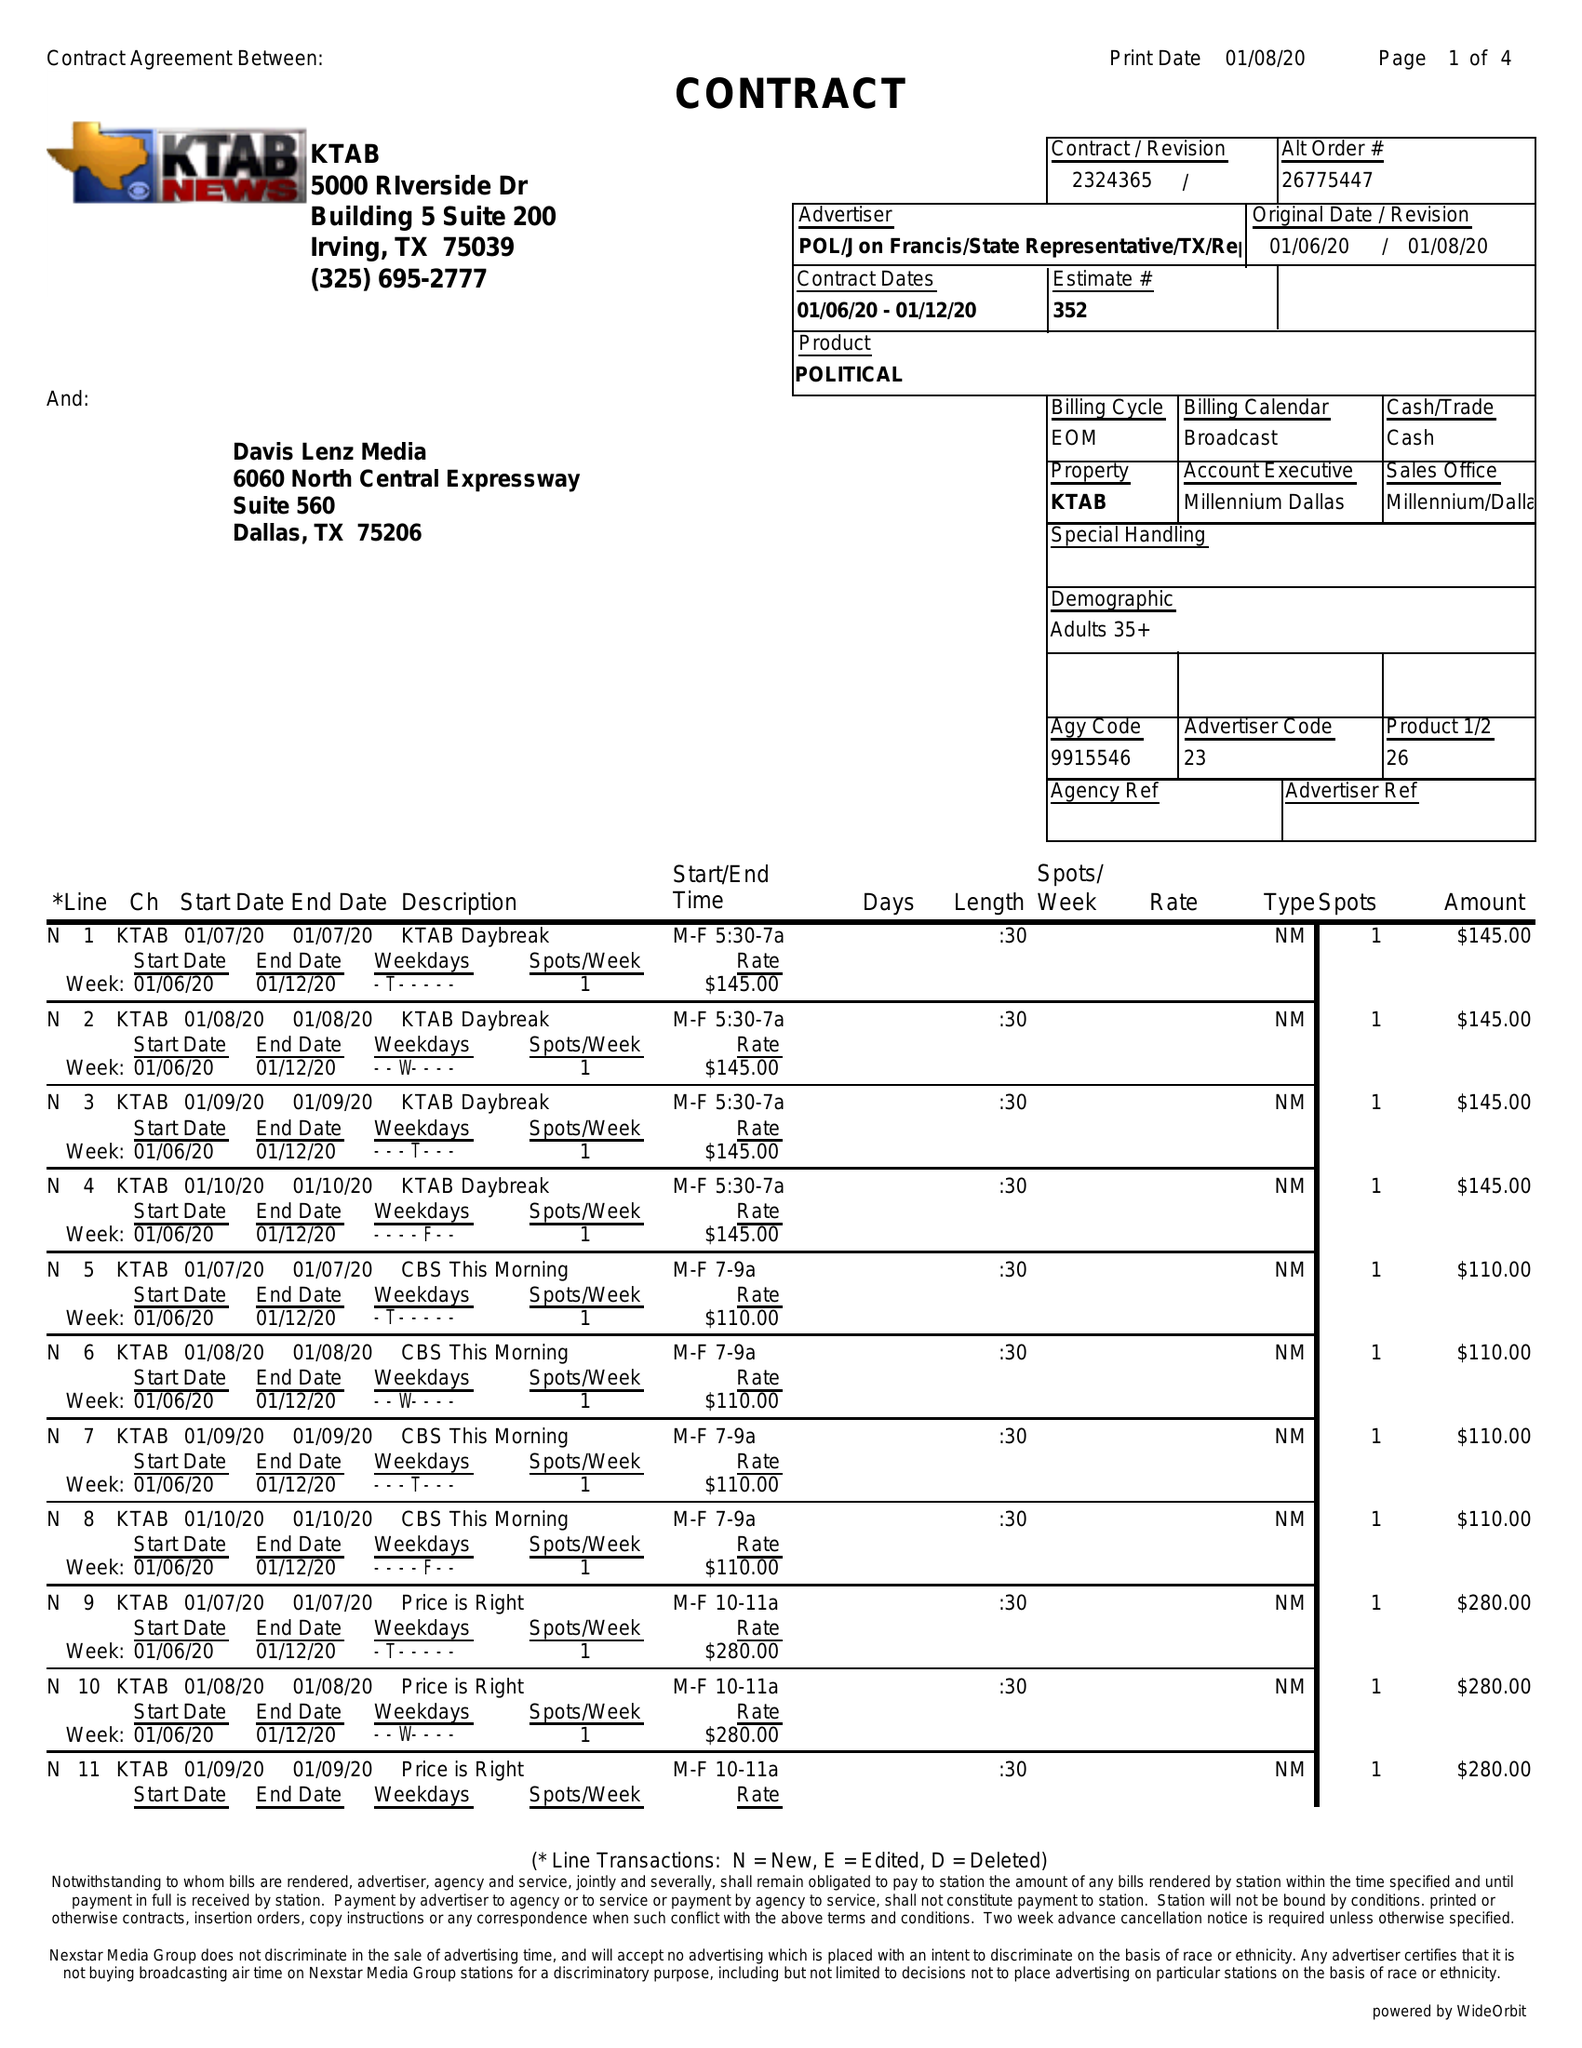What is the value for the flight_to?
Answer the question using a single word or phrase. 01/12/20 